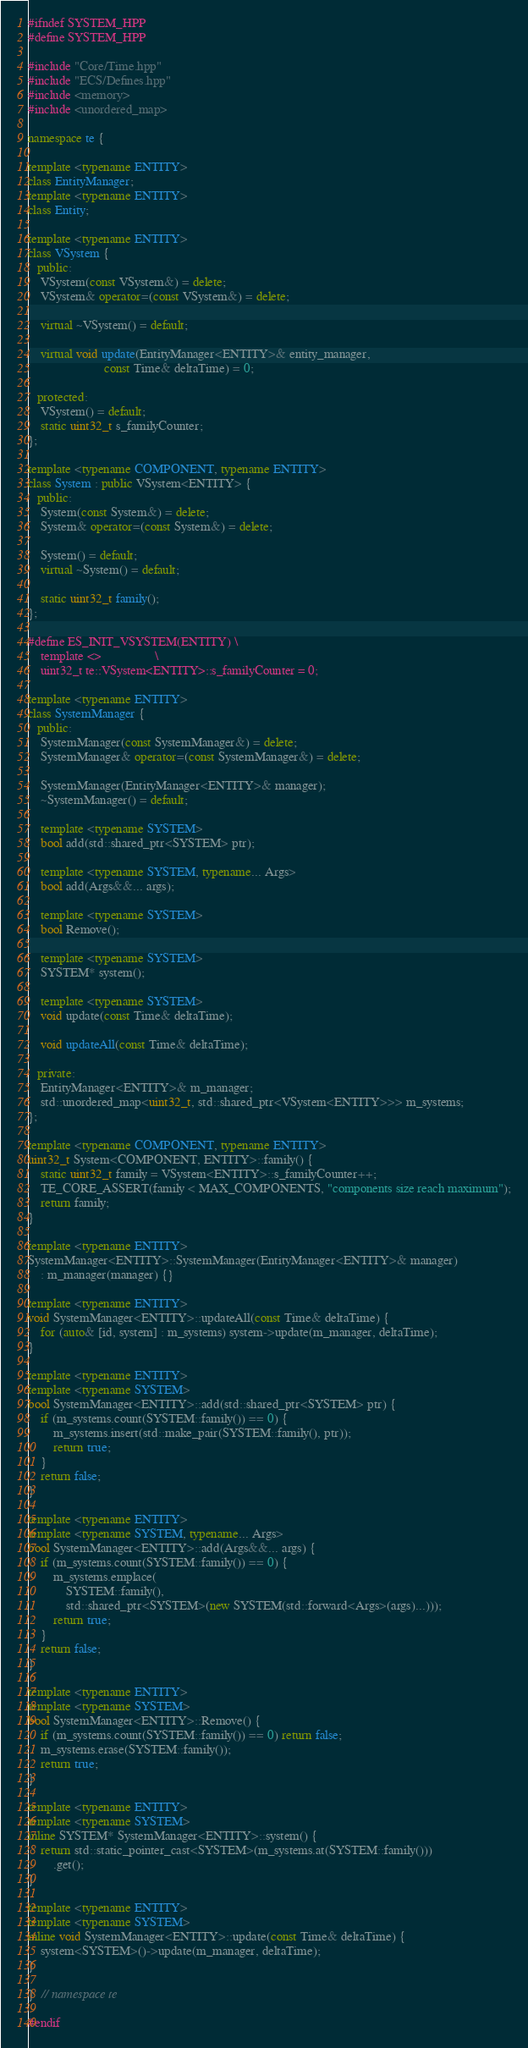<code> <loc_0><loc_0><loc_500><loc_500><_C++_>#ifndef SYSTEM_HPP
#define SYSTEM_HPP

#include "Core/Time.hpp"
#include "ECS/Defines.hpp"
#include <memory>
#include <unordered_map>

namespace te {

template <typename ENTITY>
class EntityManager;
template <typename ENTITY>
class Entity;

template <typename ENTITY>
class VSystem {
   public:
    VSystem(const VSystem&) = delete;
    VSystem& operator=(const VSystem&) = delete;

    virtual ~VSystem() = default;

    virtual void update(EntityManager<ENTITY>& entity_manager,
                        const Time& deltaTime) = 0;

   protected:
    VSystem() = default;
    static uint32_t s_familyCounter;
};

template <typename COMPONENT, typename ENTITY>
class System : public VSystem<ENTITY> {
   public:
    System(const System&) = delete;
    System& operator=(const System&) = delete;

    System() = default;
    virtual ~System() = default;

    static uint32_t family();
};

#define ES_INIT_VSYSTEM(ENTITY) \
    template <>                 \
    uint32_t te::VSystem<ENTITY>::s_familyCounter = 0;

template <typename ENTITY>
class SystemManager {
   public:
    SystemManager(const SystemManager&) = delete;
    SystemManager& operator=(const SystemManager&) = delete;

    SystemManager(EntityManager<ENTITY>& manager);
    ~SystemManager() = default;

    template <typename SYSTEM>
    bool add(std::shared_ptr<SYSTEM> ptr);

    template <typename SYSTEM, typename... Args>
    bool add(Args&&... args);

    template <typename SYSTEM>
    bool Remove();

    template <typename SYSTEM>
    SYSTEM* system();

    template <typename SYSTEM>
    void update(const Time& deltaTime);

    void updateAll(const Time& deltaTime);

   private:
    EntityManager<ENTITY>& m_manager;
    std::unordered_map<uint32_t, std::shared_ptr<VSystem<ENTITY>>> m_systems;
};

template <typename COMPONENT, typename ENTITY>
uint32_t System<COMPONENT, ENTITY>::family() {
    static uint32_t family = VSystem<ENTITY>::s_familyCounter++;
    TE_CORE_ASSERT(family < MAX_COMPONENTS, "components size reach maximum");
    return family;
}

template <typename ENTITY>
SystemManager<ENTITY>::SystemManager(EntityManager<ENTITY>& manager)
    : m_manager(manager) {}

template <typename ENTITY>
void SystemManager<ENTITY>::updateAll(const Time& deltaTime) {
    for (auto& [id, system] : m_systems) system->update(m_manager, deltaTime);
}

template <typename ENTITY>
template <typename SYSTEM>
bool SystemManager<ENTITY>::add(std::shared_ptr<SYSTEM> ptr) {
    if (m_systems.count(SYSTEM::family()) == 0) {
        m_systems.insert(std::make_pair(SYSTEM::family(), ptr));
        return true;
    }
    return false;
}

template <typename ENTITY>
template <typename SYSTEM, typename... Args>
bool SystemManager<ENTITY>::add(Args&&... args) {
    if (m_systems.count(SYSTEM::family()) == 0) {
        m_systems.emplace(
            SYSTEM::family(),
            std::shared_ptr<SYSTEM>(new SYSTEM(std::forward<Args>(args)...)));
        return true;
    }
    return false;
}

template <typename ENTITY>
template <typename SYSTEM>
bool SystemManager<ENTITY>::Remove() {
    if (m_systems.count(SYSTEM::family()) == 0) return false;
    m_systems.erase(SYSTEM::family());
    return true;
}

template <typename ENTITY>
template <typename SYSTEM>
inline SYSTEM* SystemManager<ENTITY>::system() {
    return std::static_pointer_cast<SYSTEM>(m_systems.at(SYSTEM::family()))
        .get();
}

template <typename ENTITY>
template <typename SYSTEM>
inline void SystemManager<ENTITY>::update(const Time& deltaTime) {
    system<SYSTEM>()->update(m_manager, deltaTime);
}

}  // namespace te

#endif
</code> 